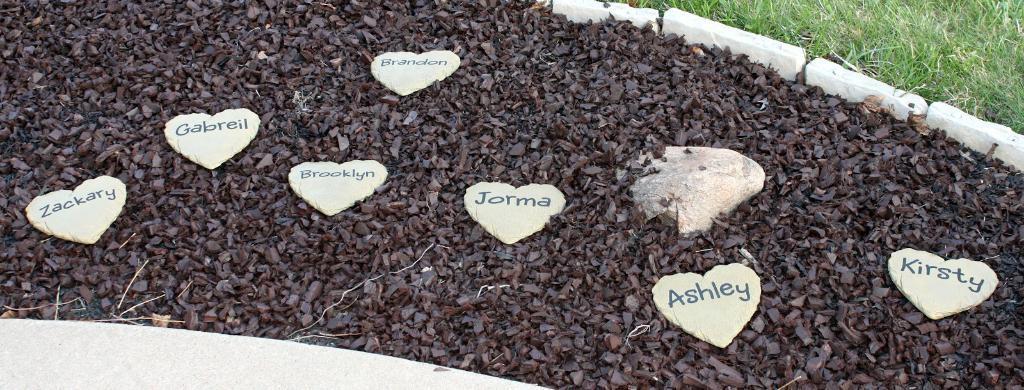Please provide a concise description of this image. In this image we can see grass and stones. Here we can see heart shaped objects with text. 